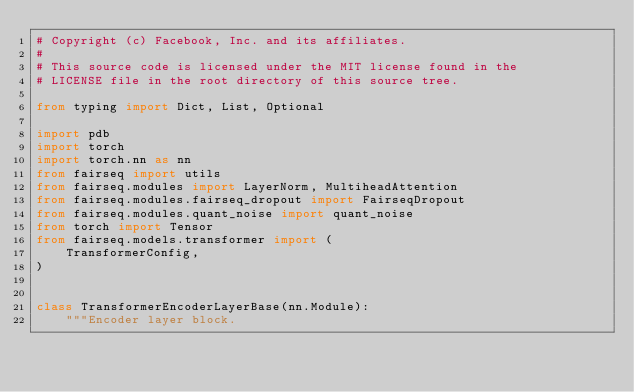Convert code to text. <code><loc_0><loc_0><loc_500><loc_500><_Python_># Copyright (c) Facebook, Inc. and its affiliates.
#
# This source code is licensed under the MIT license found in the
# LICENSE file in the root directory of this source tree.

from typing import Dict, List, Optional

import pdb
import torch
import torch.nn as nn
from fairseq import utils
from fairseq.modules import LayerNorm, MultiheadAttention
from fairseq.modules.fairseq_dropout import FairseqDropout
from fairseq.modules.quant_noise import quant_noise
from torch import Tensor
from fairseq.models.transformer import (
    TransformerConfig,
)


class TransformerEncoderLayerBase(nn.Module):
    """Encoder layer block.
</code> 